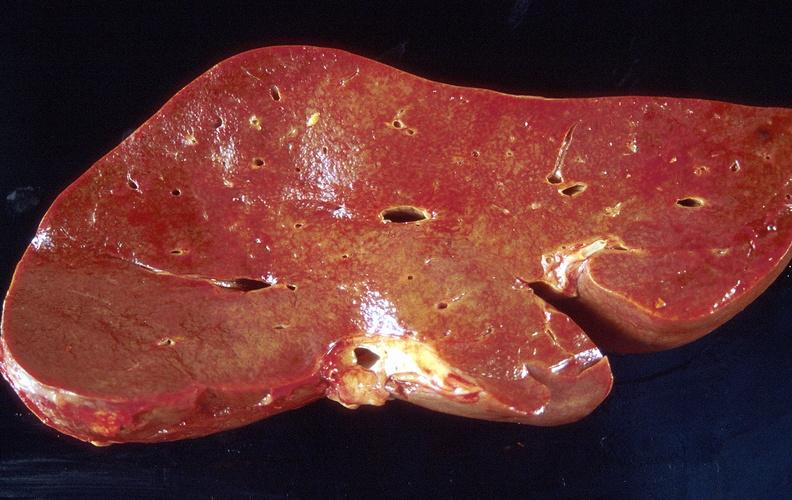s hepatobiliary present?
Answer the question using a single word or phrase. Yes 